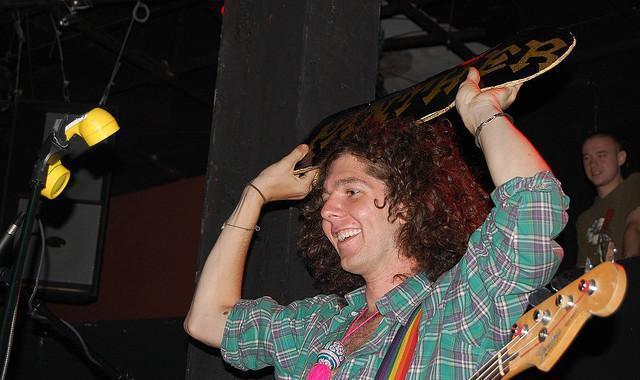How many people can you see?
Give a very brief answer. 2. 